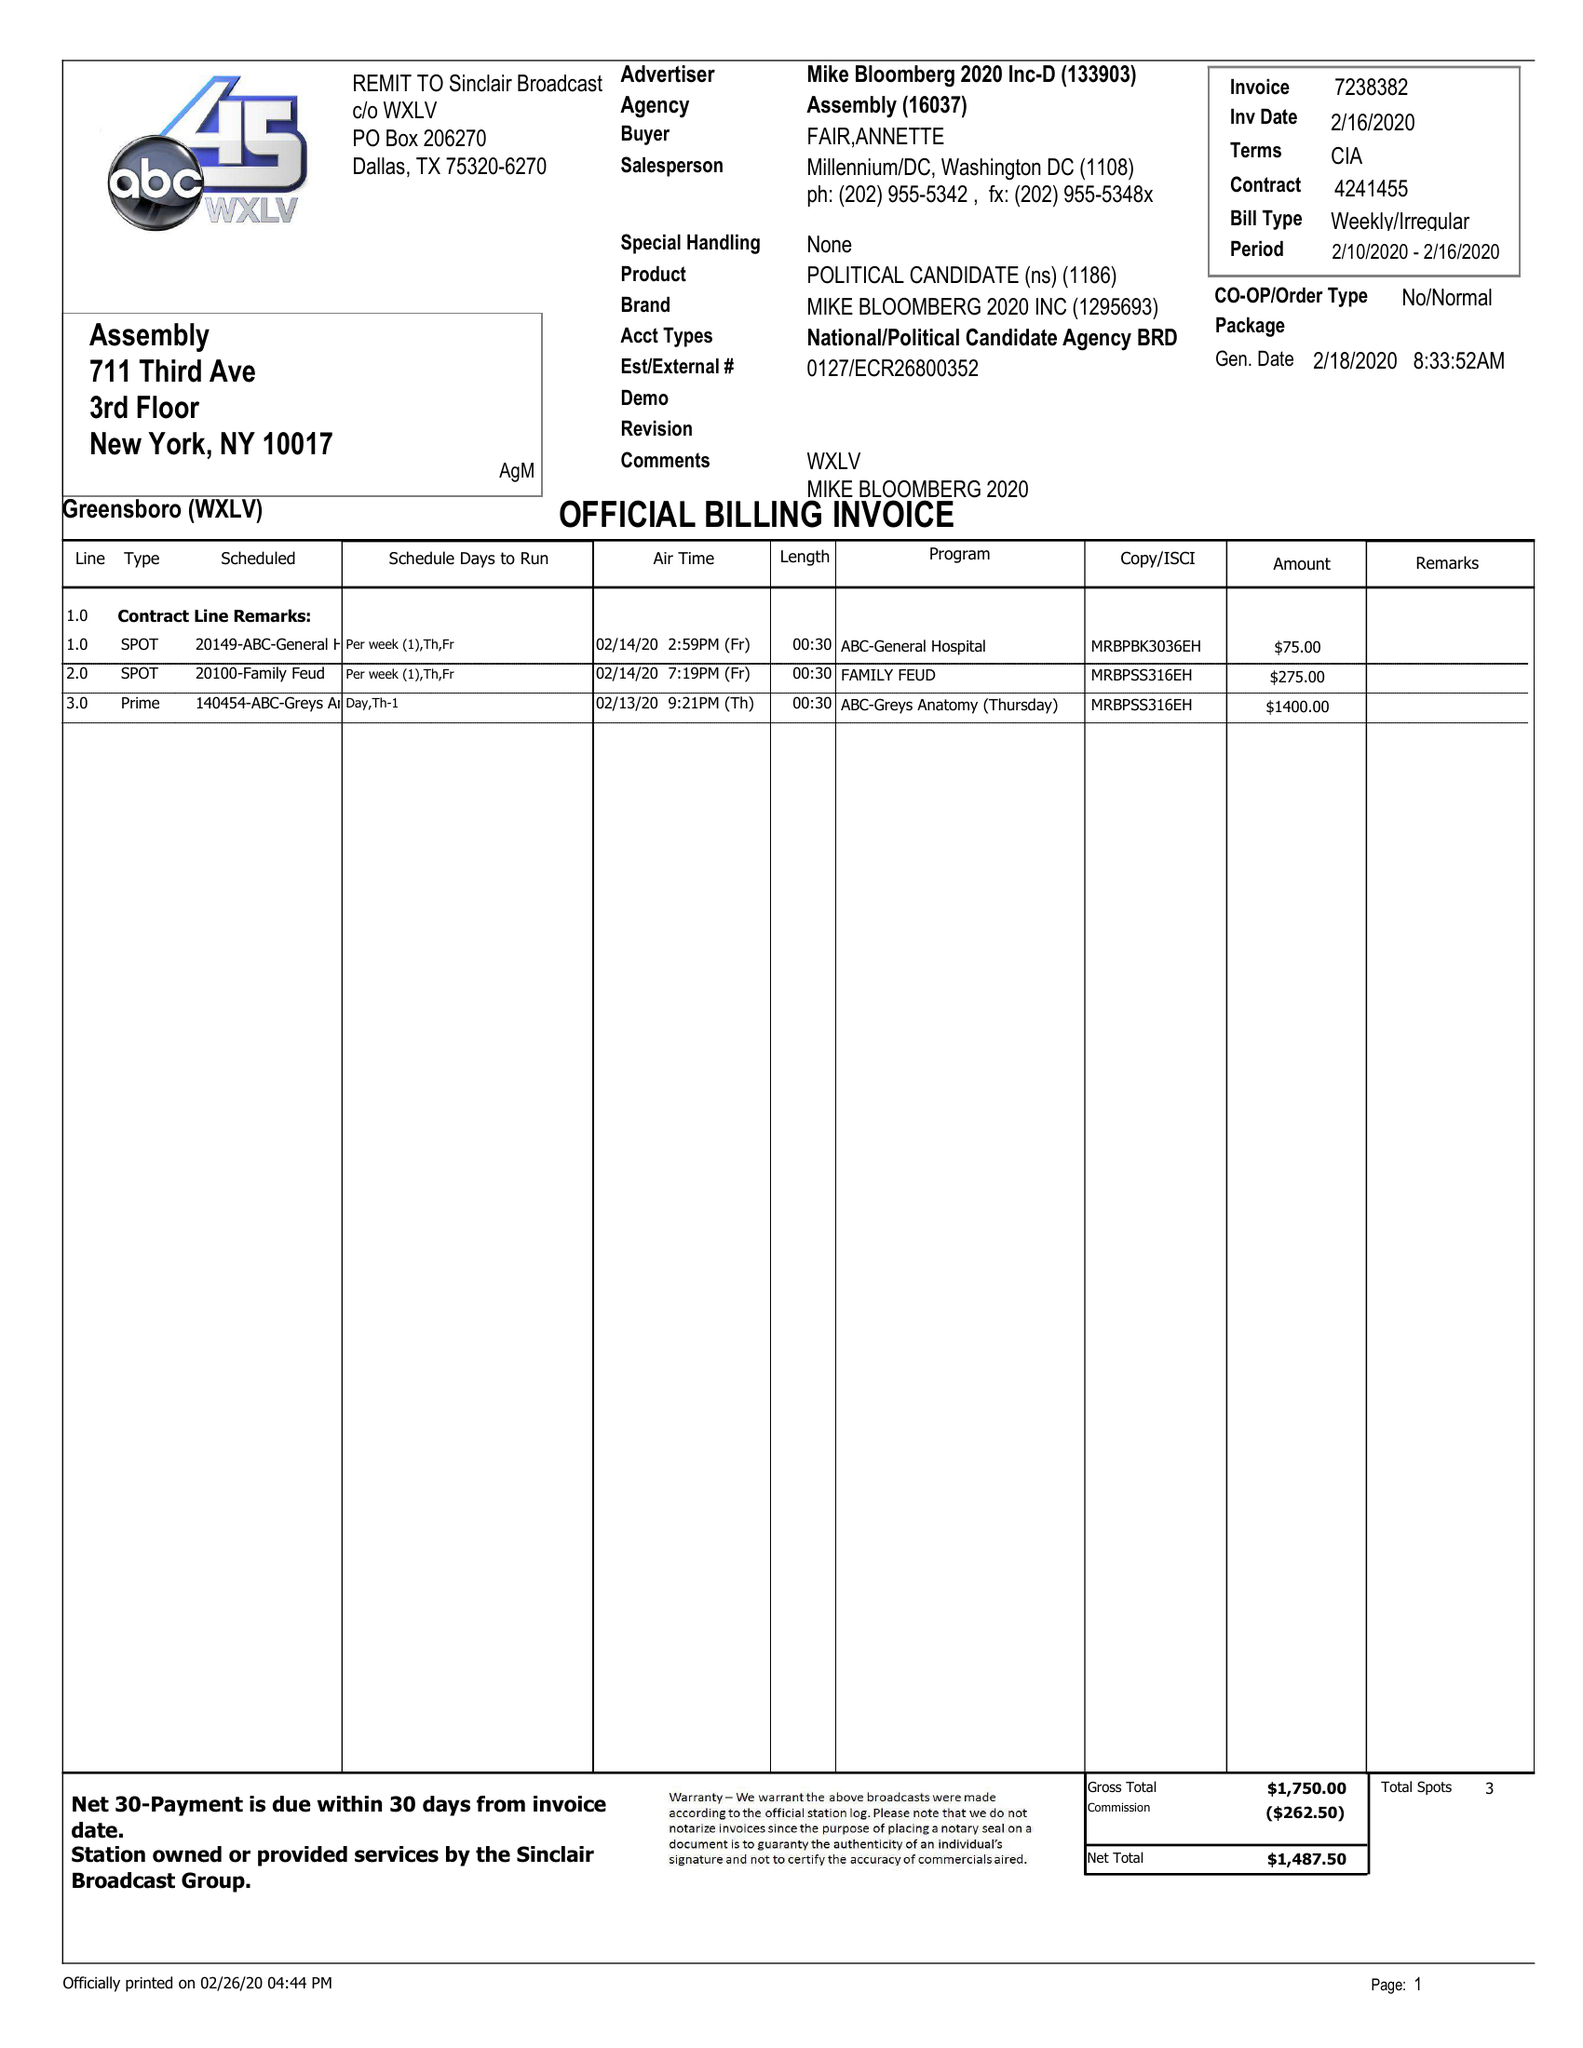What is the value for the flight_to?
Answer the question using a single word or phrase. 02/16/20 